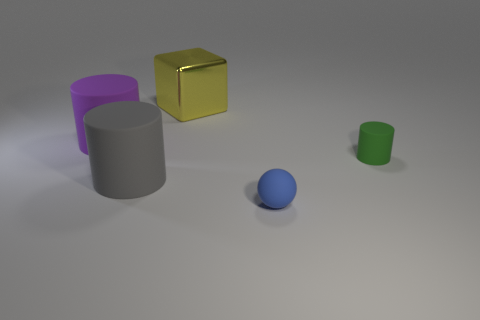Add 3 green metal cylinders. How many objects exist? 8 Subtract all cylinders. How many objects are left? 2 Add 5 balls. How many balls are left? 6 Add 3 green rubber objects. How many green rubber objects exist? 4 Subtract 1 blue balls. How many objects are left? 4 Subtract all gray cylinders. Subtract all tiny matte objects. How many objects are left? 2 